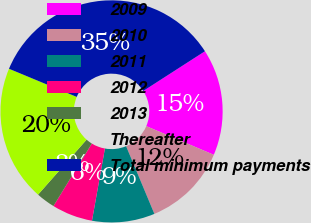Convert chart to OTSL. <chart><loc_0><loc_0><loc_500><loc_500><pie_chart><fcel>2009<fcel>2010<fcel>2011<fcel>2012<fcel>2013<fcel>Thereafter<fcel>Total minimum payments<nl><fcel>15.5%<fcel>12.31%<fcel>9.12%<fcel>5.94%<fcel>2.75%<fcel>19.76%<fcel>34.63%<nl></chart> 